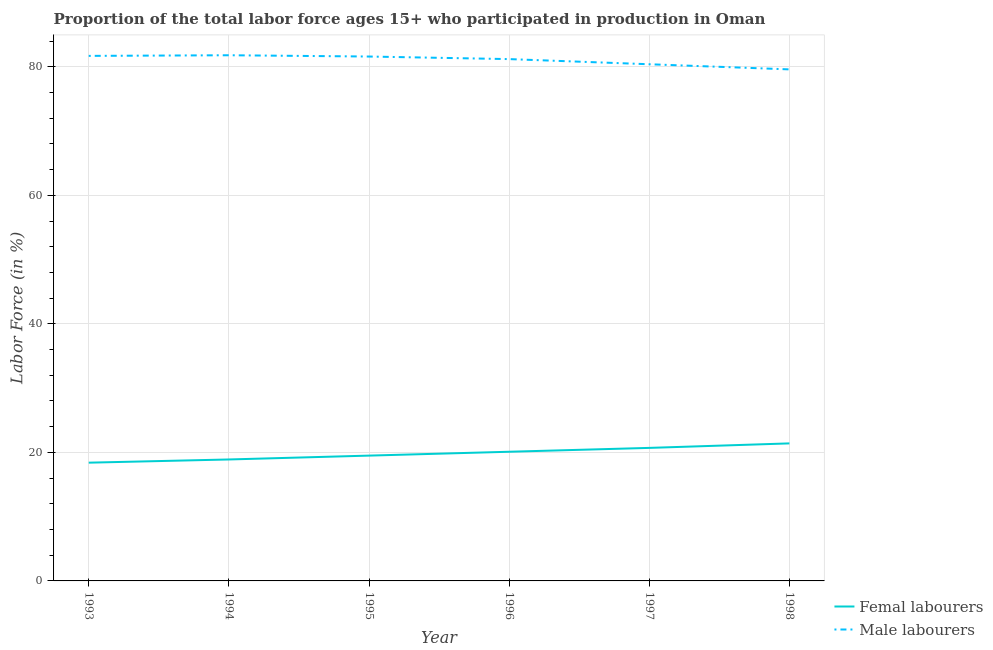How many different coloured lines are there?
Ensure brevity in your answer.  2. What is the percentage of female labor force in 1994?
Your answer should be compact. 18.9. Across all years, what is the maximum percentage of male labour force?
Offer a very short reply. 81.8. Across all years, what is the minimum percentage of male labour force?
Your answer should be very brief. 79.6. What is the total percentage of female labor force in the graph?
Give a very brief answer. 119. What is the difference between the percentage of male labour force in 1995 and the percentage of female labor force in 1998?
Provide a succinct answer. 60.2. What is the average percentage of female labor force per year?
Offer a terse response. 19.83. In the year 1998, what is the difference between the percentage of male labour force and percentage of female labor force?
Make the answer very short. 58.2. What is the ratio of the percentage of male labour force in 1994 to that in 1996?
Your response must be concise. 1.01. Is the percentage of male labour force in 1995 less than that in 1996?
Your response must be concise. No. Is the difference between the percentage of male labour force in 1997 and 1998 greater than the difference between the percentage of female labor force in 1997 and 1998?
Offer a very short reply. Yes. What is the difference between the highest and the second highest percentage of female labor force?
Make the answer very short. 0.7. What is the difference between the highest and the lowest percentage of male labour force?
Provide a short and direct response. 2.2. In how many years, is the percentage of male labour force greater than the average percentage of male labour force taken over all years?
Offer a very short reply. 4. Is the percentage of male labour force strictly greater than the percentage of female labor force over the years?
Your response must be concise. Yes. Does the graph contain any zero values?
Offer a terse response. No. Does the graph contain grids?
Ensure brevity in your answer.  Yes. How many legend labels are there?
Ensure brevity in your answer.  2. How are the legend labels stacked?
Your answer should be compact. Vertical. What is the title of the graph?
Offer a terse response. Proportion of the total labor force ages 15+ who participated in production in Oman. What is the label or title of the X-axis?
Your response must be concise. Year. What is the label or title of the Y-axis?
Your answer should be compact. Labor Force (in %). What is the Labor Force (in %) of Femal labourers in 1993?
Give a very brief answer. 18.4. What is the Labor Force (in %) in Male labourers in 1993?
Your answer should be very brief. 81.7. What is the Labor Force (in %) of Femal labourers in 1994?
Keep it short and to the point. 18.9. What is the Labor Force (in %) in Male labourers in 1994?
Offer a terse response. 81.8. What is the Labor Force (in %) of Male labourers in 1995?
Make the answer very short. 81.6. What is the Labor Force (in %) in Femal labourers in 1996?
Offer a very short reply. 20.1. What is the Labor Force (in %) of Male labourers in 1996?
Make the answer very short. 81.2. What is the Labor Force (in %) of Femal labourers in 1997?
Make the answer very short. 20.7. What is the Labor Force (in %) in Male labourers in 1997?
Provide a succinct answer. 80.4. What is the Labor Force (in %) in Femal labourers in 1998?
Your answer should be very brief. 21.4. What is the Labor Force (in %) in Male labourers in 1998?
Provide a short and direct response. 79.6. Across all years, what is the maximum Labor Force (in %) of Femal labourers?
Make the answer very short. 21.4. Across all years, what is the maximum Labor Force (in %) of Male labourers?
Make the answer very short. 81.8. Across all years, what is the minimum Labor Force (in %) in Femal labourers?
Offer a terse response. 18.4. Across all years, what is the minimum Labor Force (in %) of Male labourers?
Provide a short and direct response. 79.6. What is the total Labor Force (in %) in Femal labourers in the graph?
Provide a short and direct response. 119. What is the total Labor Force (in %) of Male labourers in the graph?
Provide a succinct answer. 486.3. What is the difference between the Labor Force (in %) of Femal labourers in 1993 and that in 1995?
Ensure brevity in your answer.  -1.1. What is the difference between the Labor Force (in %) in Male labourers in 1993 and that in 1995?
Your answer should be very brief. 0.1. What is the difference between the Labor Force (in %) of Femal labourers in 1993 and that in 1996?
Offer a very short reply. -1.7. What is the difference between the Labor Force (in %) of Femal labourers in 1993 and that in 1998?
Your response must be concise. -3. What is the difference between the Labor Force (in %) in Male labourers in 1993 and that in 1998?
Give a very brief answer. 2.1. What is the difference between the Labor Force (in %) in Male labourers in 1994 and that in 1995?
Ensure brevity in your answer.  0.2. What is the difference between the Labor Force (in %) of Femal labourers in 1994 and that in 1997?
Make the answer very short. -1.8. What is the difference between the Labor Force (in %) in Male labourers in 1994 and that in 1997?
Your answer should be compact. 1.4. What is the difference between the Labor Force (in %) of Male labourers in 1995 and that in 1996?
Your answer should be very brief. 0.4. What is the difference between the Labor Force (in %) in Femal labourers in 1995 and that in 1997?
Your answer should be very brief. -1.2. What is the difference between the Labor Force (in %) in Male labourers in 1995 and that in 1998?
Provide a short and direct response. 2. What is the difference between the Labor Force (in %) in Femal labourers in 1996 and that in 1998?
Keep it short and to the point. -1.3. What is the difference between the Labor Force (in %) in Male labourers in 1996 and that in 1998?
Offer a very short reply. 1.6. What is the difference between the Labor Force (in %) of Femal labourers in 1993 and the Labor Force (in %) of Male labourers in 1994?
Offer a very short reply. -63.4. What is the difference between the Labor Force (in %) of Femal labourers in 1993 and the Labor Force (in %) of Male labourers in 1995?
Offer a very short reply. -63.2. What is the difference between the Labor Force (in %) of Femal labourers in 1993 and the Labor Force (in %) of Male labourers in 1996?
Ensure brevity in your answer.  -62.8. What is the difference between the Labor Force (in %) in Femal labourers in 1993 and the Labor Force (in %) in Male labourers in 1997?
Offer a terse response. -62. What is the difference between the Labor Force (in %) in Femal labourers in 1993 and the Labor Force (in %) in Male labourers in 1998?
Give a very brief answer. -61.2. What is the difference between the Labor Force (in %) of Femal labourers in 1994 and the Labor Force (in %) of Male labourers in 1995?
Make the answer very short. -62.7. What is the difference between the Labor Force (in %) of Femal labourers in 1994 and the Labor Force (in %) of Male labourers in 1996?
Your answer should be very brief. -62.3. What is the difference between the Labor Force (in %) in Femal labourers in 1994 and the Labor Force (in %) in Male labourers in 1997?
Your answer should be very brief. -61.5. What is the difference between the Labor Force (in %) in Femal labourers in 1994 and the Labor Force (in %) in Male labourers in 1998?
Give a very brief answer. -60.7. What is the difference between the Labor Force (in %) in Femal labourers in 1995 and the Labor Force (in %) in Male labourers in 1996?
Make the answer very short. -61.7. What is the difference between the Labor Force (in %) in Femal labourers in 1995 and the Labor Force (in %) in Male labourers in 1997?
Provide a succinct answer. -60.9. What is the difference between the Labor Force (in %) in Femal labourers in 1995 and the Labor Force (in %) in Male labourers in 1998?
Your answer should be compact. -60.1. What is the difference between the Labor Force (in %) in Femal labourers in 1996 and the Labor Force (in %) in Male labourers in 1997?
Ensure brevity in your answer.  -60.3. What is the difference between the Labor Force (in %) of Femal labourers in 1996 and the Labor Force (in %) of Male labourers in 1998?
Keep it short and to the point. -59.5. What is the difference between the Labor Force (in %) in Femal labourers in 1997 and the Labor Force (in %) in Male labourers in 1998?
Your answer should be compact. -58.9. What is the average Labor Force (in %) in Femal labourers per year?
Offer a terse response. 19.83. What is the average Labor Force (in %) of Male labourers per year?
Your answer should be compact. 81.05. In the year 1993, what is the difference between the Labor Force (in %) of Femal labourers and Labor Force (in %) of Male labourers?
Your answer should be compact. -63.3. In the year 1994, what is the difference between the Labor Force (in %) of Femal labourers and Labor Force (in %) of Male labourers?
Offer a very short reply. -62.9. In the year 1995, what is the difference between the Labor Force (in %) in Femal labourers and Labor Force (in %) in Male labourers?
Your answer should be compact. -62.1. In the year 1996, what is the difference between the Labor Force (in %) in Femal labourers and Labor Force (in %) in Male labourers?
Offer a very short reply. -61.1. In the year 1997, what is the difference between the Labor Force (in %) in Femal labourers and Labor Force (in %) in Male labourers?
Provide a short and direct response. -59.7. In the year 1998, what is the difference between the Labor Force (in %) of Femal labourers and Labor Force (in %) of Male labourers?
Your response must be concise. -58.2. What is the ratio of the Labor Force (in %) in Femal labourers in 1993 to that in 1994?
Provide a short and direct response. 0.97. What is the ratio of the Labor Force (in %) of Femal labourers in 1993 to that in 1995?
Your answer should be compact. 0.94. What is the ratio of the Labor Force (in %) in Femal labourers in 1993 to that in 1996?
Your response must be concise. 0.92. What is the ratio of the Labor Force (in %) in Femal labourers in 1993 to that in 1997?
Your answer should be very brief. 0.89. What is the ratio of the Labor Force (in %) of Male labourers in 1993 to that in 1997?
Your answer should be very brief. 1.02. What is the ratio of the Labor Force (in %) of Femal labourers in 1993 to that in 1998?
Make the answer very short. 0.86. What is the ratio of the Labor Force (in %) in Male labourers in 1993 to that in 1998?
Your response must be concise. 1.03. What is the ratio of the Labor Force (in %) of Femal labourers in 1994 to that in 1995?
Your answer should be compact. 0.97. What is the ratio of the Labor Force (in %) in Femal labourers in 1994 to that in 1996?
Keep it short and to the point. 0.94. What is the ratio of the Labor Force (in %) of Male labourers in 1994 to that in 1996?
Your answer should be very brief. 1.01. What is the ratio of the Labor Force (in %) in Femal labourers in 1994 to that in 1997?
Ensure brevity in your answer.  0.91. What is the ratio of the Labor Force (in %) in Male labourers in 1994 to that in 1997?
Offer a terse response. 1.02. What is the ratio of the Labor Force (in %) in Femal labourers in 1994 to that in 1998?
Provide a short and direct response. 0.88. What is the ratio of the Labor Force (in %) in Male labourers in 1994 to that in 1998?
Provide a succinct answer. 1.03. What is the ratio of the Labor Force (in %) in Femal labourers in 1995 to that in 1996?
Offer a terse response. 0.97. What is the ratio of the Labor Force (in %) of Male labourers in 1995 to that in 1996?
Keep it short and to the point. 1. What is the ratio of the Labor Force (in %) of Femal labourers in 1995 to that in 1997?
Make the answer very short. 0.94. What is the ratio of the Labor Force (in %) of Male labourers in 1995 to that in 1997?
Make the answer very short. 1.01. What is the ratio of the Labor Force (in %) in Femal labourers in 1995 to that in 1998?
Ensure brevity in your answer.  0.91. What is the ratio of the Labor Force (in %) in Male labourers in 1995 to that in 1998?
Keep it short and to the point. 1.03. What is the ratio of the Labor Force (in %) of Femal labourers in 1996 to that in 1998?
Provide a succinct answer. 0.94. What is the ratio of the Labor Force (in %) of Male labourers in 1996 to that in 1998?
Offer a very short reply. 1.02. What is the ratio of the Labor Force (in %) in Femal labourers in 1997 to that in 1998?
Your answer should be compact. 0.97. What is the difference between the highest and the second highest Labor Force (in %) in Femal labourers?
Your answer should be compact. 0.7. What is the difference between the highest and the second highest Labor Force (in %) of Male labourers?
Make the answer very short. 0.1. What is the difference between the highest and the lowest Labor Force (in %) in Femal labourers?
Ensure brevity in your answer.  3. 